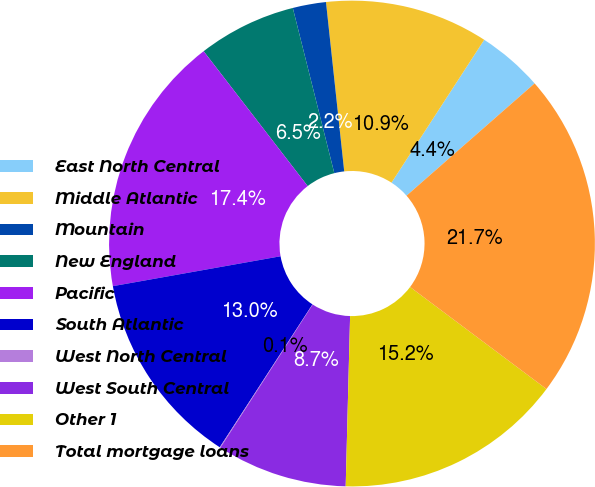Convert chart to OTSL. <chart><loc_0><loc_0><loc_500><loc_500><pie_chart><fcel>East North Central<fcel>Middle Atlantic<fcel>Mountain<fcel>New England<fcel>Pacific<fcel>South Atlantic<fcel>West North Central<fcel>West South Central<fcel>Other 1<fcel>Total mortgage loans<nl><fcel>4.38%<fcel>10.87%<fcel>2.21%<fcel>6.54%<fcel>17.35%<fcel>13.03%<fcel>0.05%<fcel>8.7%<fcel>15.19%<fcel>21.68%<nl></chart> 